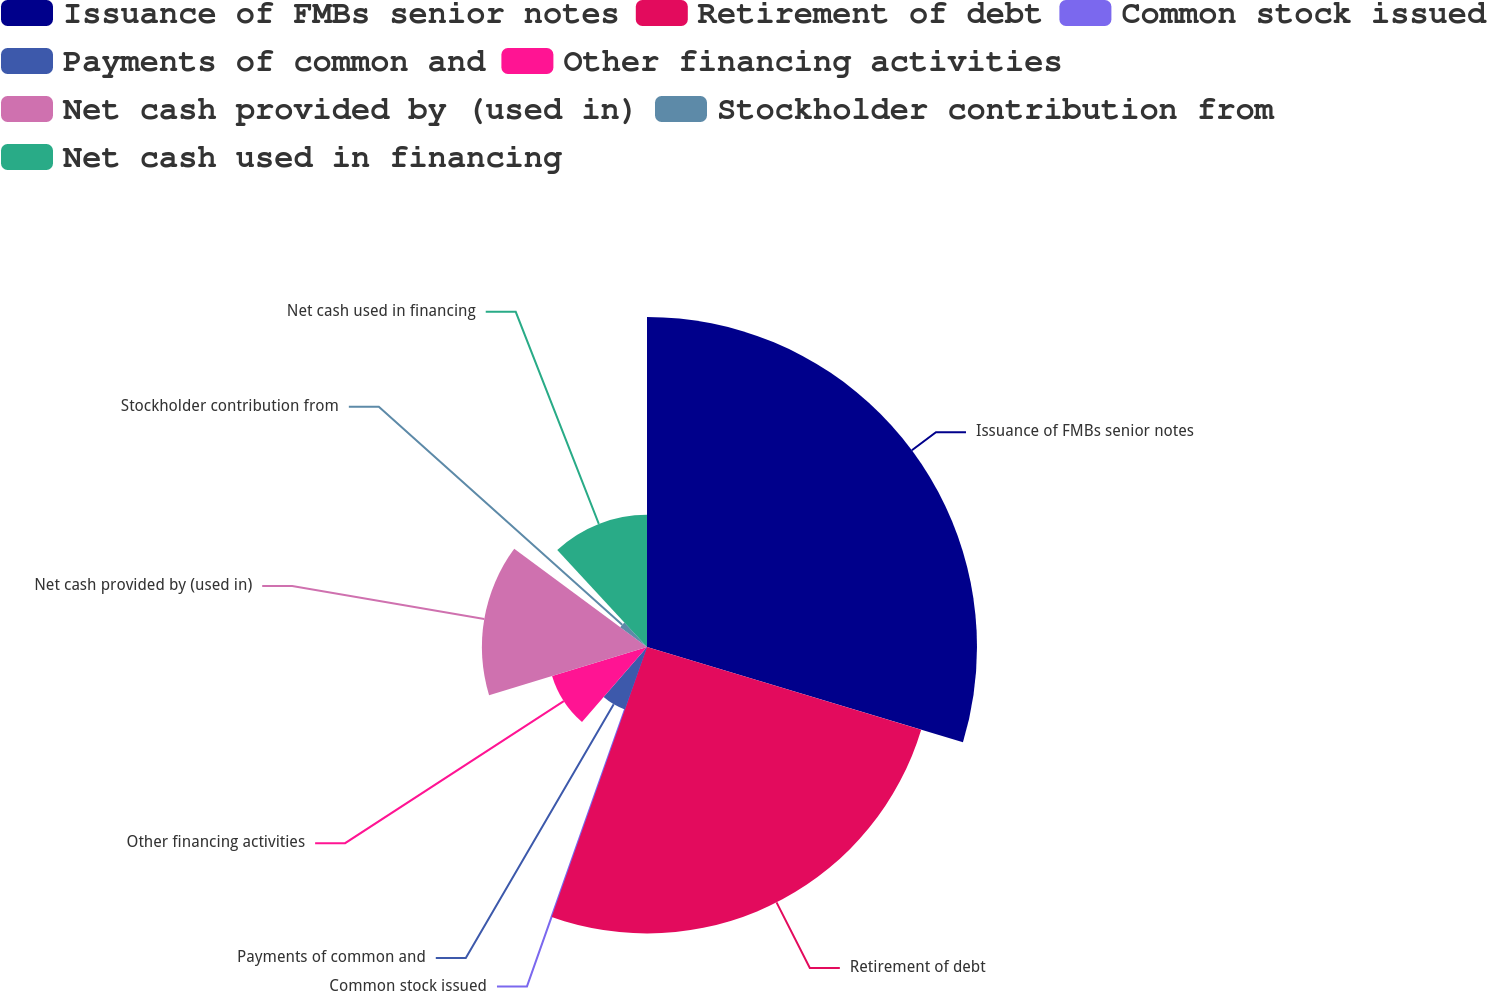Convert chart to OTSL. <chart><loc_0><loc_0><loc_500><loc_500><pie_chart><fcel>Issuance of FMBs senior notes<fcel>Retirement of debt<fcel>Common stock issued<fcel>Payments of common and<fcel>Other financing activities<fcel>Net cash provided by (used in)<fcel>Stockholder contribution from<fcel>Net cash used in financing<nl><fcel>29.66%<fcel>25.74%<fcel>0.02%<fcel>5.95%<fcel>8.92%<fcel>14.84%<fcel>2.99%<fcel>11.88%<nl></chart> 